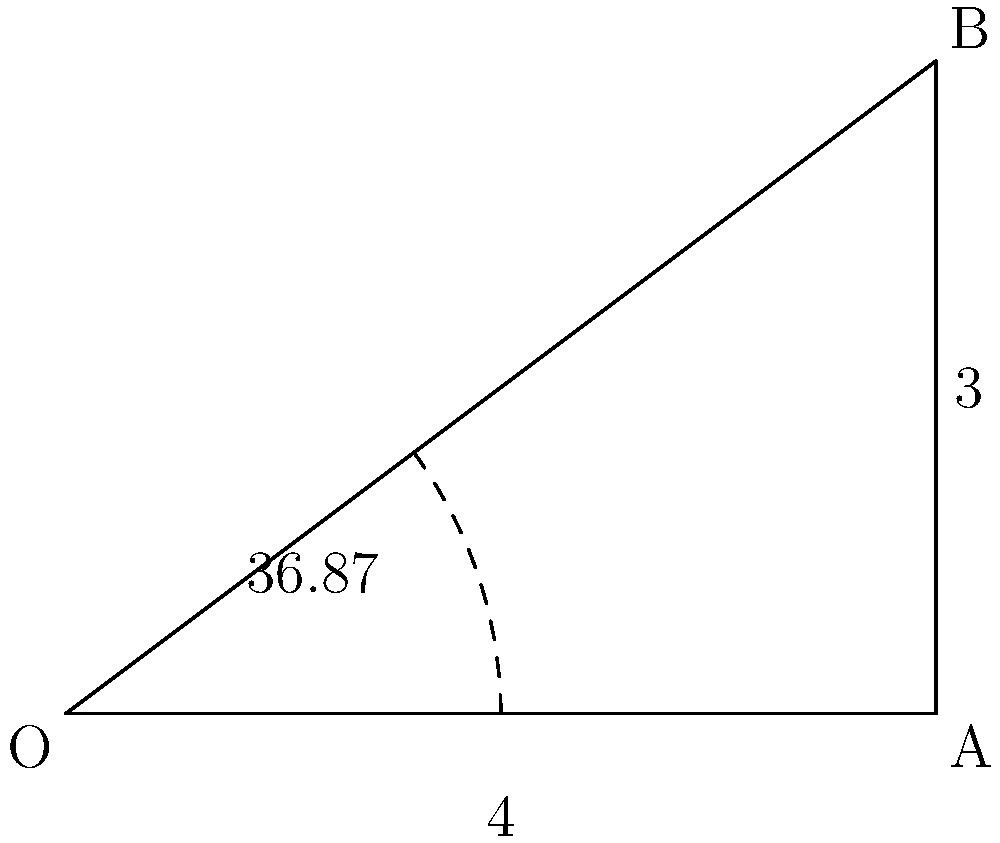A dancer is mimicking a bird's wing movement during flight. At a specific moment, their arm forms a right-angled triangle with their torso, where the upper arm (OA) is 4 units long, and the forearm (AB) is 3 units long. What is the angle (in degrees) between the upper arm and the torso, representing the bird's wing angle during this phase of flight? To solve this problem, we'll use trigonometry:

1) The dancer's arm forms a right-angled triangle OAB, where:
   - OA (upper arm) = 4 units
   - AB (forearm) = 3 units
   - OB (torso to hand) forms the hypotenuse

2) We need to find angle AOB, which is opposite to side AB.

3) In a right-angled triangle, we can use the tangent function:

   $\tan(\theta) = \frac{\text{opposite}}{\text{adjacent}} = \frac{AB}{OA} = \frac{3}{4}$

4) To find $\theta$, we use the inverse tangent (arctangent) function:

   $\theta = \tan^{-1}(\frac{3}{4})$

5) Using a calculator or mathematical software:

   $\theta \approx 36.87°$

This angle represents the bird's wing angle relative to its body during this specific phase of flight, as mimicked by the dancer.
Answer: $36.87°$ 